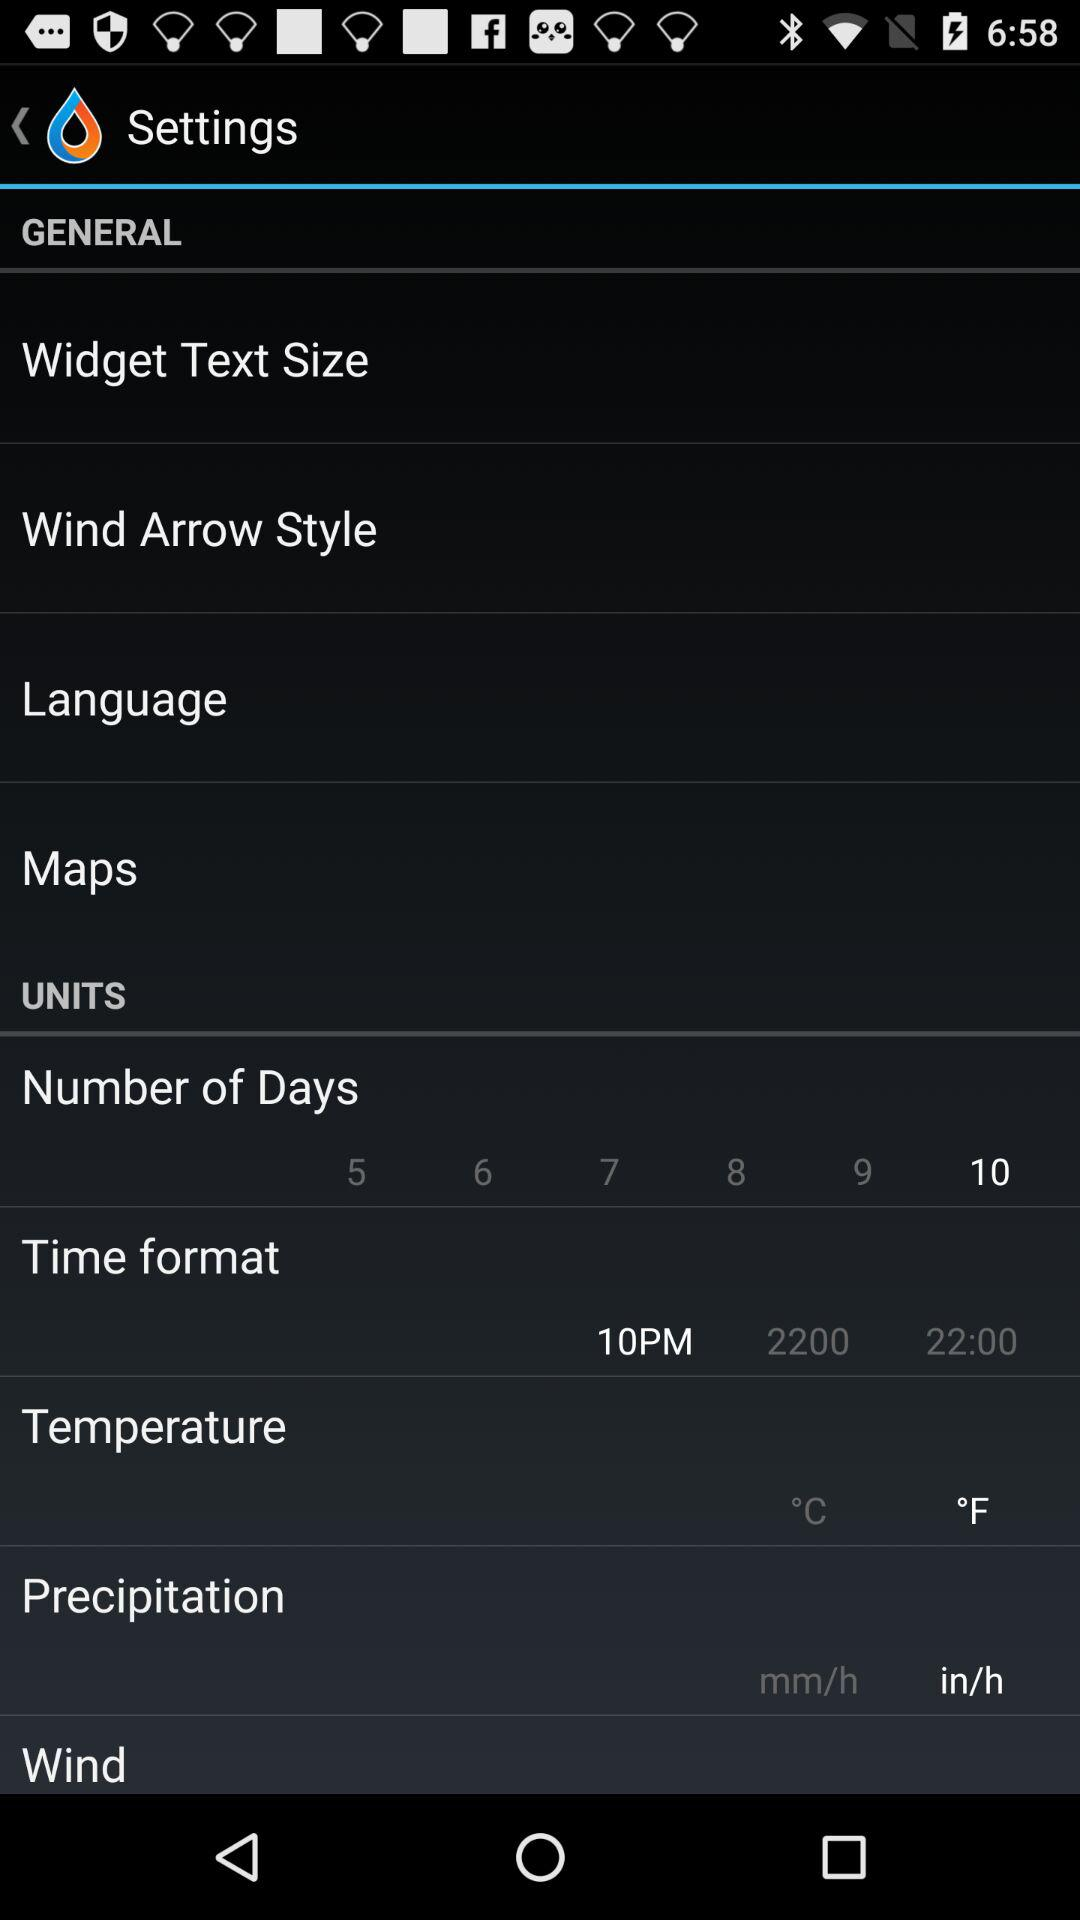What temperature unit has been selected? The selected unit is "°F". 